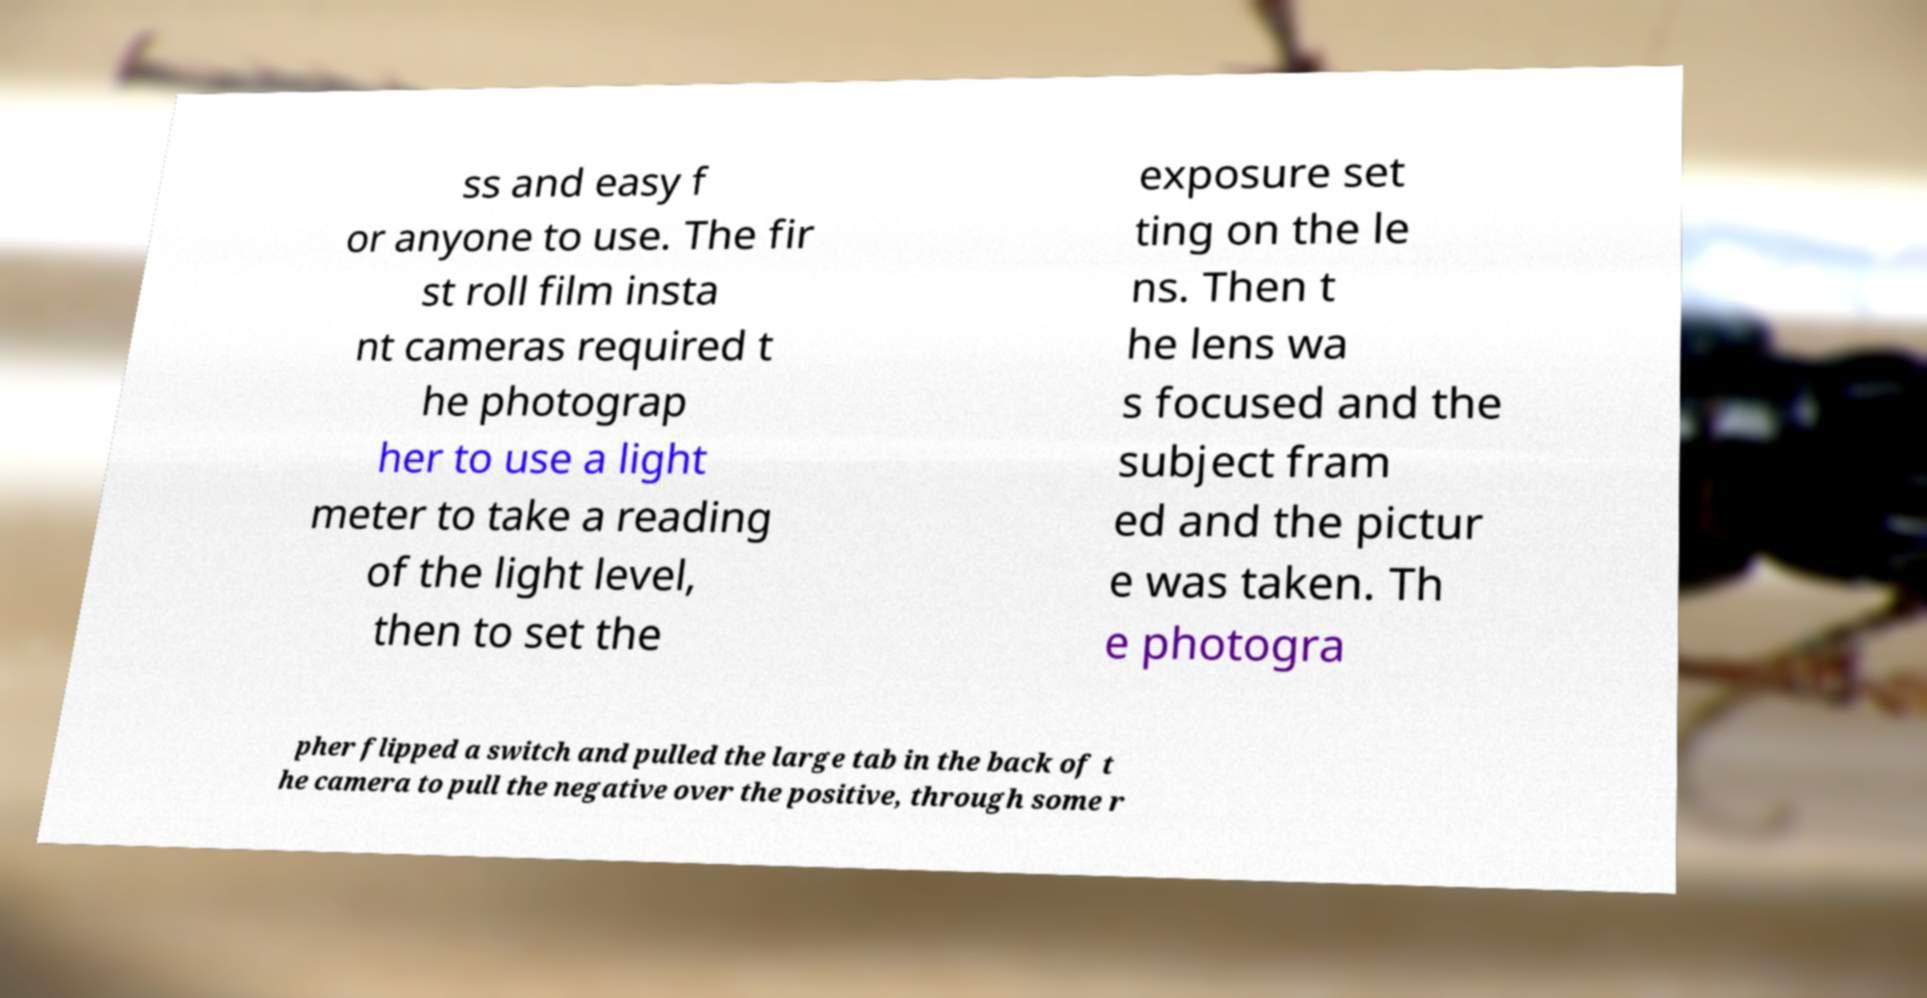What messages or text are displayed in this image? I need them in a readable, typed format. ss and easy f or anyone to use. The fir st roll film insta nt cameras required t he photograp her to use a light meter to take a reading of the light level, then to set the exposure set ting on the le ns. Then t he lens wa s focused and the subject fram ed and the pictur e was taken. Th e photogra pher flipped a switch and pulled the large tab in the back of t he camera to pull the negative over the positive, through some r 